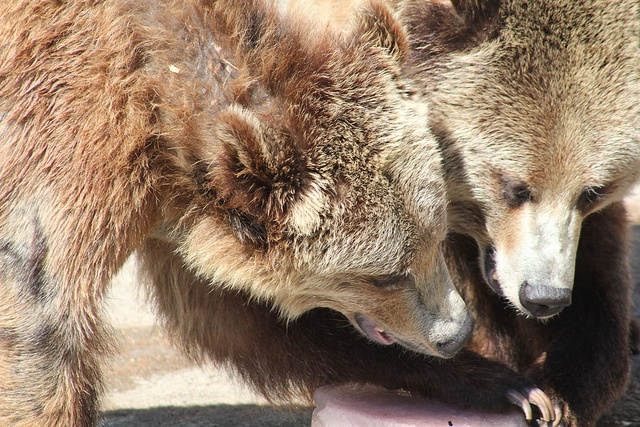Describe the objects in this image and their specific colors. I can see bear in tan and gray tones and bear in tan, black, and gray tones in this image. 